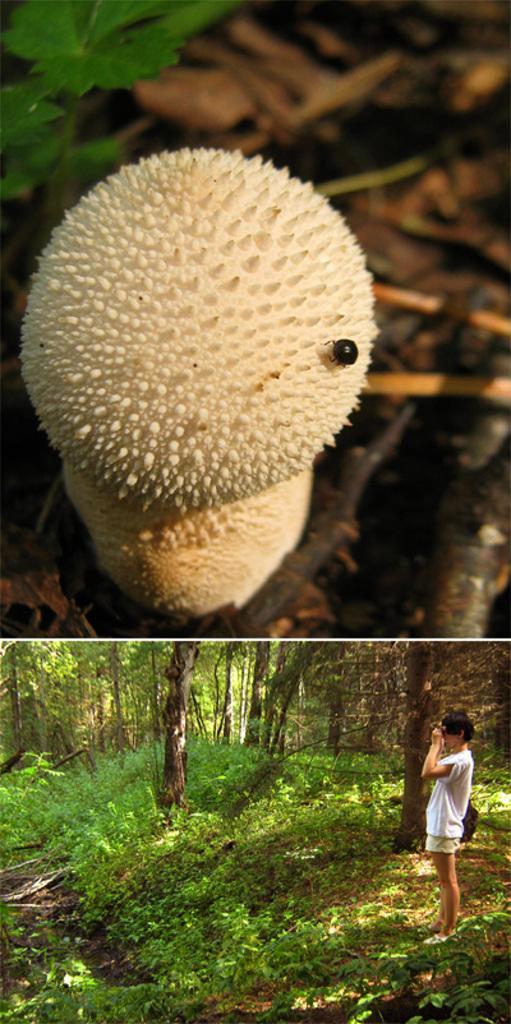Could you give a brief overview of what you see in this image? It is a collage picture. Here we can see some white color object. There is an insect on it. Background we can see a plant. At the bottom, we can see a human is standing. Here we can see so many trees and plants. 